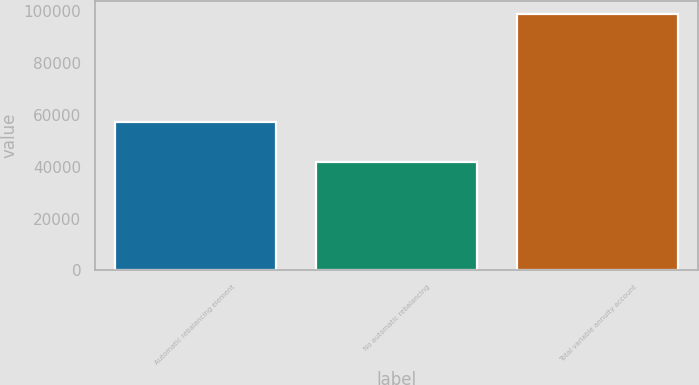<chart> <loc_0><loc_0><loc_500><loc_500><bar_chart><fcel>Automatic rebalancing element<fcel>No automatic rebalancing<fcel>Total variable annuity account<nl><fcel>57336<fcel>41693<fcel>99029<nl></chart> 